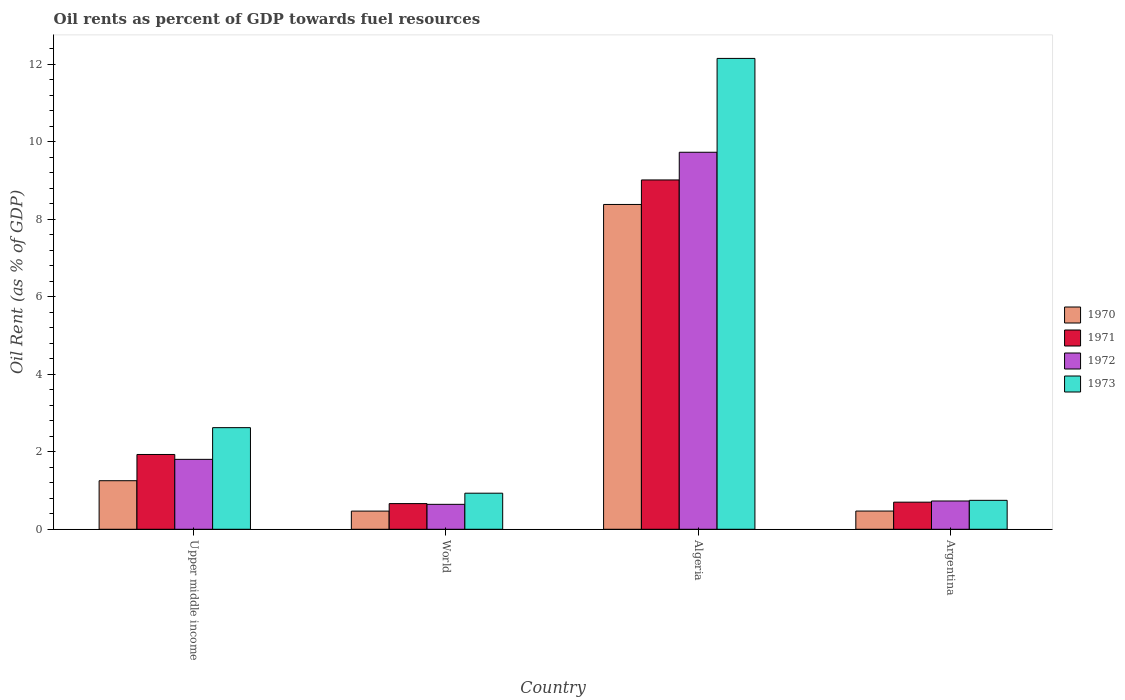How many different coloured bars are there?
Provide a succinct answer. 4. How many groups of bars are there?
Provide a short and direct response. 4. Are the number of bars on each tick of the X-axis equal?
Make the answer very short. Yes. What is the label of the 2nd group of bars from the left?
Your answer should be very brief. World. In how many cases, is the number of bars for a given country not equal to the number of legend labels?
Provide a succinct answer. 0. What is the oil rent in 1970 in World?
Provide a succinct answer. 0.47. Across all countries, what is the maximum oil rent in 1973?
Provide a succinct answer. 12.15. Across all countries, what is the minimum oil rent in 1971?
Ensure brevity in your answer.  0.66. In which country was the oil rent in 1970 maximum?
Make the answer very short. Algeria. What is the total oil rent in 1972 in the graph?
Your answer should be very brief. 12.91. What is the difference between the oil rent in 1971 in Algeria and that in World?
Keep it short and to the point. 8.35. What is the difference between the oil rent in 1971 in Algeria and the oil rent in 1972 in World?
Your answer should be compact. 8.37. What is the average oil rent in 1971 per country?
Ensure brevity in your answer.  3.08. What is the difference between the oil rent of/in 1970 and oil rent of/in 1971 in Upper middle income?
Provide a short and direct response. -0.68. In how many countries, is the oil rent in 1970 greater than 1.6 %?
Make the answer very short. 1. What is the ratio of the oil rent in 1971 in Algeria to that in Upper middle income?
Provide a succinct answer. 4.67. What is the difference between the highest and the second highest oil rent in 1973?
Make the answer very short. -1.69. What is the difference between the highest and the lowest oil rent in 1971?
Provide a succinct answer. 8.35. In how many countries, is the oil rent in 1973 greater than the average oil rent in 1973 taken over all countries?
Your response must be concise. 1. What does the 4th bar from the left in Upper middle income represents?
Your answer should be very brief. 1973. Is it the case that in every country, the sum of the oil rent in 1971 and oil rent in 1972 is greater than the oil rent in 1973?
Provide a short and direct response. Yes. How many countries are there in the graph?
Keep it short and to the point. 4. What is the difference between two consecutive major ticks on the Y-axis?
Ensure brevity in your answer.  2. Are the values on the major ticks of Y-axis written in scientific E-notation?
Your response must be concise. No. Does the graph contain any zero values?
Offer a very short reply. No. Does the graph contain grids?
Give a very brief answer. No. How many legend labels are there?
Provide a short and direct response. 4. How are the legend labels stacked?
Keep it short and to the point. Vertical. What is the title of the graph?
Keep it short and to the point. Oil rents as percent of GDP towards fuel resources. What is the label or title of the X-axis?
Provide a succinct answer. Country. What is the label or title of the Y-axis?
Make the answer very short. Oil Rent (as % of GDP). What is the Oil Rent (as % of GDP) of 1970 in Upper middle income?
Make the answer very short. 1.25. What is the Oil Rent (as % of GDP) of 1971 in Upper middle income?
Ensure brevity in your answer.  1.93. What is the Oil Rent (as % of GDP) in 1972 in Upper middle income?
Ensure brevity in your answer.  1.8. What is the Oil Rent (as % of GDP) in 1973 in Upper middle income?
Offer a very short reply. 2.62. What is the Oil Rent (as % of GDP) in 1970 in World?
Offer a terse response. 0.47. What is the Oil Rent (as % of GDP) in 1971 in World?
Offer a very short reply. 0.66. What is the Oil Rent (as % of GDP) in 1972 in World?
Provide a succinct answer. 0.64. What is the Oil Rent (as % of GDP) of 1973 in World?
Give a very brief answer. 0.93. What is the Oil Rent (as % of GDP) in 1970 in Algeria?
Give a very brief answer. 8.38. What is the Oil Rent (as % of GDP) in 1971 in Algeria?
Offer a terse response. 9.02. What is the Oil Rent (as % of GDP) of 1972 in Algeria?
Your answer should be very brief. 9.73. What is the Oil Rent (as % of GDP) in 1973 in Algeria?
Keep it short and to the point. 12.15. What is the Oil Rent (as % of GDP) of 1970 in Argentina?
Offer a terse response. 0.47. What is the Oil Rent (as % of GDP) of 1971 in Argentina?
Keep it short and to the point. 0.7. What is the Oil Rent (as % of GDP) of 1972 in Argentina?
Your response must be concise. 0.73. What is the Oil Rent (as % of GDP) in 1973 in Argentina?
Give a very brief answer. 0.75. Across all countries, what is the maximum Oil Rent (as % of GDP) in 1970?
Give a very brief answer. 8.38. Across all countries, what is the maximum Oil Rent (as % of GDP) of 1971?
Ensure brevity in your answer.  9.02. Across all countries, what is the maximum Oil Rent (as % of GDP) of 1972?
Keep it short and to the point. 9.73. Across all countries, what is the maximum Oil Rent (as % of GDP) in 1973?
Ensure brevity in your answer.  12.15. Across all countries, what is the minimum Oil Rent (as % of GDP) of 1970?
Offer a terse response. 0.47. Across all countries, what is the minimum Oil Rent (as % of GDP) of 1971?
Your answer should be compact. 0.66. Across all countries, what is the minimum Oil Rent (as % of GDP) of 1972?
Offer a very short reply. 0.64. Across all countries, what is the minimum Oil Rent (as % of GDP) of 1973?
Your answer should be very brief. 0.75. What is the total Oil Rent (as % of GDP) in 1970 in the graph?
Offer a very short reply. 10.58. What is the total Oil Rent (as % of GDP) of 1971 in the graph?
Provide a succinct answer. 12.31. What is the total Oil Rent (as % of GDP) in 1972 in the graph?
Your response must be concise. 12.91. What is the total Oil Rent (as % of GDP) of 1973 in the graph?
Keep it short and to the point. 16.45. What is the difference between the Oil Rent (as % of GDP) of 1970 in Upper middle income and that in World?
Your response must be concise. 0.78. What is the difference between the Oil Rent (as % of GDP) in 1971 in Upper middle income and that in World?
Your answer should be very brief. 1.27. What is the difference between the Oil Rent (as % of GDP) of 1972 in Upper middle income and that in World?
Make the answer very short. 1.16. What is the difference between the Oil Rent (as % of GDP) of 1973 in Upper middle income and that in World?
Offer a very short reply. 1.69. What is the difference between the Oil Rent (as % of GDP) of 1970 in Upper middle income and that in Algeria?
Ensure brevity in your answer.  -7.13. What is the difference between the Oil Rent (as % of GDP) in 1971 in Upper middle income and that in Algeria?
Make the answer very short. -7.09. What is the difference between the Oil Rent (as % of GDP) of 1972 in Upper middle income and that in Algeria?
Ensure brevity in your answer.  -7.93. What is the difference between the Oil Rent (as % of GDP) in 1973 in Upper middle income and that in Algeria?
Offer a terse response. -9.53. What is the difference between the Oil Rent (as % of GDP) of 1970 in Upper middle income and that in Argentina?
Your answer should be very brief. 0.78. What is the difference between the Oil Rent (as % of GDP) in 1971 in Upper middle income and that in Argentina?
Your response must be concise. 1.23. What is the difference between the Oil Rent (as % of GDP) of 1972 in Upper middle income and that in Argentina?
Provide a succinct answer. 1.07. What is the difference between the Oil Rent (as % of GDP) of 1973 in Upper middle income and that in Argentina?
Offer a terse response. 1.88. What is the difference between the Oil Rent (as % of GDP) in 1970 in World and that in Algeria?
Offer a very short reply. -7.91. What is the difference between the Oil Rent (as % of GDP) in 1971 in World and that in Algeria?
Provide a succinct answer. -8.35. What is the difference between the Oil Rent (as % of GDP) of 1972 in World and that in Algeria?
Offer a very short reply. -9.09. What is the difference between the Oil Rent (as % of GDP) of 1973 in World and that in Algeria?
Provide a short and direct response. -11.22. What is the difference between the Oil Rent (as % of GDP) of 1970 in World and that in Argentina?
Give a very brief answer. -0. What is the difference between the Oil Rent (as % of GDP) in 1971 in World and that in Argentina?
Your answer should be compact. -0.04. What is the difference between the Oil Rent (as % of GDP) of 1972 in World and that in Argentina?
Your answer should be very brief. -0.09. What is the difference between the Oil Rent (as % of GDP) of 1973 in World and that in Argentina?
Keep it short and to the point. 0.18. What is the difference between the Oil Rent (as % of GDP) of 1970 in Algeria and that in Argentina?
Provide a short and direct response. 7.91. What is the difference between the Oil Rent (as % of GDP) in 1971 in Algeria and that in Argentina?
Keep it short and to the point. 8.32. What is the difference between the Oil Rent (as % of GDP) in 1972 in Algeria and that in Argentina?
Your response must be concise. 9. What is the difference between the Oil Rent (as % of GDP) in 1973 in Algeria and that in Argentina?
Your response must be concise. 11.41. What is the difference between the Oil Rent (as % of GDP) of 1970 in Upper middle income and the Oil Rent (as % of GDP) of 1971 in World?
Offer a terse response. 0.59. What is the difference between the Oil Rent (as % of GDP) in 1970 in Upper middle income and the Oil Rent (as % of GDP) in 1972 in World?
Your answer should be very brief. 0.61. What is the difference between the Oil Rent (as % of GDP) in 1970 in Upper middle income and the Oil Rent (as % of GDP) in 1973 in World?
Offer a very short reply. 0.32. What is the difference between the Oil Rent (as % of GDP) of 1971 in Upper middle income and the Oil Rent (as % of GDP) of 1972 in World?
Your response must be concise. 1.29. What is the difference between the Oil Rent (as % of GDP) of 1972 in Upper middle income and the Oil Rent (as % of GDP) of 1973 in World?
Provide a short and direct response. 0.87. What is the difference between the Oil Rent (as % of GDP) of 1970 in Upper middle income and the Oil Rent (as % of GDP) of 1971 in Algeria?
Your answer should be very brief. -7.76. What is the difference between the Oil Rent (as % of GDP) in 1970 in Upper middle income and the Oil Rent (as % of GDP) in 1972 in Algeria?
Offer a terse response. -8.48. What is the difference between the Oil Rent (as % of GDP) in 1970 in Upper middle income and the Oil Rent (as % of GDP) in 1973 in Algeria?
Your response must be concise. -10.9. What is the difference between the Oil Rent (as % of GDP) in 1971 in Upper middle income and the Oil Rent (as % of GDP) in 1973 in Algeria?
Provide a succinct answer. -10.22. What is the difference between the Oil Rent (as % of GDP) of 1972 in Upper middle income and the Oil Rent (as % of GDP) of 1973 in Algeria?
Give a very brief answer. -10.35. What is the difference between the Oil Rent (as % of GDP) of 1970 in Upper middle income and the Oil Rent (as % of GDP) of 1971 in Argentina?
Offer a terse response. 0.55. What is the difference between the Oil Rent (as % of GDP) of 1970 in Upper middle income and the Oil Rent (as % of GDP) of 1972 in Argentina?
Make the answer very short. 0.52. What is the difference between the Oil Rent (as % of GDP) of 1970 in Upper middle income and the Oil Rent (as % of GDP) of 1973 in Argentina?
Your response must be concise. 0.51. What is the difference between the Oil Rent (as % of GDP) in 1971 in Upper middle income and the Oil Rent (as % of GDP) in 1972 in Argentina?
Ensure brevity in your answer.  1.2. What is the difference between the Oil Rent (as % of GDP) of 1971 in Upper middle income and the Oil Rent (as % of GDP) of 1973 in Argentina?
Make the answer very short. 1.18. What is the difference between the Oil Rent (as % of GDP) of 1972 in Upper middle income and the Oil Rent (as % of GDP) of 1973 in Argentina?
Your answer should be very brief. 1.06. What is the difference between the Oil Rent (as % of GDP) in 1970 in World and the Oil Rent (as % of GDP) in 1971 in Algeria?
Offer a terse response. -8.55. What is the difference between the Oil Rent (as % of GDP) in 1970 in World and the Oil Rent (as % of GDP) in 1972 in Algeria?
Provide a succinct answer. -9.26. What is the difference between the Oil Rent (as % of GDP) of 1970 in World and the Oil Rent (as % of GDP) of 1973 in Algeria?
Keep it short and to the point. -11.68. What is the difference between the Oil Rent (as % of GDP) of 1971 in World and the Oil Rent (as % of GDP) of 1972 in Algeria?
Provide a short and direct response. -9.07. What is the difference between the Oil Rent (as % of GDP) in 1971 in World and the Oil Rent (as % of GDP) in 1973 in Algeria?
Keep it short and to the point. -11.49. What is the difference between the Oil Rent (as % of GDP) of 1972 in World and the Oil Rent (as % of GDP) of 1973 in Algeria?
Keep it short and to the point. -11.51. What is the difference between the Oil Rent (as % of GDP) in 1970 in World and the Oil Rent (as % of GDP) in 1971 in Argentina?
Your answer should be very brief. -0.23. What is the difference between the Oil Rent (as % of GDP) of 1970 in World and the Oil Rent (as % of GDP) of 1972 in Argentina?
Give a very brief answer. -0.26. What is the difference between the Oil Rent (as % of GDP) of 1970 in World and the Oil Rent (as % of GDP) of 1973 in Argentina?
Your response must be concise. -0.28. What is the difference between the Oil Rent (as % of GDP) of 1971 in World and the Oil Rent (as % of GDP) of 1972 in Argentina?
Offer a very short reply. -0.07. What is the difference between the Oil Rent (as % of GDP) of 1971 in World and the Oil Rent (as % of GDP) of 1973 in Argentina?
Provide a succinct answer. -0.08. What is the difference between the Oil Rent (as % of GDP) of 1972 in World and the Oil Rent (as % of GDP) of 1973 in Argentina?
Your response must be concise. -0.1. What is the difference between the Oil Rent (as % of GDP) of 1970 in Algeria and the Oil Rent (as % of GDP) of 1971 in Argentina?
Your response must be concise. 7.68. What is the difference between the Oil Rent (as % of GDP) of 1970 in Algeria and the Oil Rent (as % of GDP) of 1972 in Argentina?
Your response must be concise. 7.65. What is the difference between the Oil Rent (as % of GDP) in 1970 in Algeria and the Oil Rent (as % of GDP) in 1973 in Argentina?
Offer a terse response. 7.64. What is the difference between the Oil Rent (as % of GDP) of 1971 in Algeria and the Oil Rent (as % of GDP) of 1972 in Argentina?
Your answer should be very brief. 8.29. What is the difference between the Oil Rent (as % of GDP) of 1971 in Algeria and the Oil Rent (as % of GDP) of 1973 in Argentina?
Provide a succinct answer. 8.27. What is the difference between the Oil Rent (as % of GDP) of 1972 in Algeria and the Oil Rent (as % of GDP) of 1973 in Argentina?
Give a very brief answer. 8.98. What is the average Oil Rent (as % of GDP) of 1970 per country?
Your response must be concise. 2.64. What is the average Oil Rent (as % of GDP) of 1971 per country?
Your response must be concise. 3.08. What is the average Oil Rent (as % of GDP) of 1972 per country?
Your answer should be compact. 3.23. What is the average Oil Rent (as % of GDP) of 1973 per country?
Keep it short and to the point. 4.11. What is the difference between the Oil Rent (as % of GDP) of 1970 and Oil Rent (as % of GDP) of 1971 in Upper middle income?
Keep it short and to the point. -0.68. What is the difference between the Oil Rent (as % of GDP) in 1970 and Oil Rent (as % of GDP) in 1972 in Upper middle income?
Your response must be concise. -0.55. What is the difference between the Oil Rent (as % of GDP) in 1970 and Oil Rent (as % of GDP) in 1973 in Upper middle income?
Your response must be concise. -1.37. What is the difference between the Oil Rent (as % of GDP) of 1971 and Oil Rent (as % of GDP) of 1972 in Upper middle income?
Provide a short and direct response. 0.13. What is the difference between the Oil Rent (as % of GDP) of 1971 and Oil Rent (as % of GDP) of 1973 in Upper middle income?
Your answer should be very brief. -0.69. What is the difference between the Oil Rent (as % of GDP) in 1972 and Oil Rent (as % of GDP) in 1973 in Upper middle income?
Provide a succinct answer. -0.82. What is the difference between the Oil Rent (as % of GDP) of 1970 and Oil Rent (as % of GDP) of 1971 in World?
Offer a terse response. -0.19. What is the difference between the Oil Rent (as % of GDP) in 1970 and Oil Rent (as % of GDP) in 1972 in World?
Provide a succinct answer. -0.17. What is the difference between the Oil Rent (as % of GDP) in 1970 and Oil Rent (as % of GDP) in 1973 in World?
Keep it short and to the point. -0.46. What is the difference between the Oil Rent (as % of GDP) in 1971 and Oil Rent (as % of GDP) in 1972 in World?
Offer a terse response. 0.02. What is the difference between the Oil Rent (as % of GDP) of 1971 and Oil Rent (as % of GDP) of 1973 in World?
Offer a very short reply. -0.27. What is the difference between the Oil Rent (as % of GDP) in 1972 and Oil Rent (as % of GDP) in 1973 in World?
Your response must be concise. -0.29. What is the difference between the Oil Rent (as % of GDP) in 1970 and Oil Rent (as % of GDP) in 1971 in Algeria?
Provide a succinct answer. -0.63. What is the difference between the Oil Rent (as % of GDP) of 1970 and Oil Rent (as % of GDP) of 1972 in Algeria?
Your answer should be compact. -1.35. What is the difference between the Oil Rent (as % of GDP) in 1970 and Oil Rent (as % of GDP) in 1973 in Algeria?
Offer a terse response. -3.77. What is the difference between the Oil Rent (as % of GDP) of 1971 and Oil Rent (as % of GDP) of 1972 in Algeria?
Offer a terse response. -0.71. What is the difference between the Oil Rent (as % of GDP) of 1971 and Oil Rent (as % of GDP) of 1973 in Algeria?
Provide a succinct answer. -3.14. What is the difference between the Oil Rent (as % of GDP) of 1972 and Oil Rent (as % of GDP) of 1973 in Algeria?
Keep it short and to the point. -2.42. What is the difference between the Oil Rent (as % of GDP) of 1970 and Oil Rent (as % of GDP) of 1971 in Argentina?
Your answer should be compact. -0.23. What is the difference between the Oil Rent (as % of GDP) of 1970 and Oil Rent (as % of GDP) of 1972 in Argentina?
Keep it short and to the point. -0.26. What is the difference between the Oil Rent (as % of GDP) in 1970 and Oil Rent (as % of GDP) in 1973 in Argentina?
Ensure brevity in your answer.  -0.28. What is the difference between the Oil Rent (as % of GDP) in 1971 and Oil Rent (as % of GDP) in 1972 in Argentina?
Provide a succinct answer. -0.03. What is the difference between the Oil Rent (as % of GDP) in 1971 and Oil Rent (as % of GDP) in 1973 in Argentina?
Your answer should be compact. -0.05. What is the difference between the Oil Rent (as % of GDP) in 1972 and Oil Rent (as % of GDP) in 1973 in Argentina?
Provide a succinct answer. -0.02. What is the ratio of the Oil Rent (as % of GDP) in 1970 in Upper middle income to that in World?
Your answer should be very brief. 2.67. What is the ratio of the Oil Rent (as % of GDP) of 1971 in Upper middle income to that in World?
Offer a very short reply. 2.91. What is the ratio of the Oil Rent (as % of GDP) of 1972 in Upper middle income to that in World?
Give a very brief answer. 2.8. What is the ratio of the Oil Rent (as % of GDP) of 1973 in Upper middle income to that in World?
Provide a succinct answer. 2.82. What is the ratio of the Oil Rent (as % of GDP) in 1970 in Upper middle income to that in Algeria?
Provide a succinct answer. 0.15. What is the ratio of the Oil Rent (as % of GDP) in 1971 in Upper middle income to that in Algeria?
Offer a very short reply. 0.21. What is the ratio of the Oil Rent (as % of GDP) of 1972 in Upper middle income to that in Algeria?
Provide a short and direct response. 0.19. What is the ratio of the Oil Rent (as % of GDP) in 1973 in Upper middle income to that in Algeria?
Make the answer very short. 0.22. What is the ratio of the Oil Rent (as % of GDP) in 1970 in Upper middle income to that in Argentina?
Your answer should be very brief. 2.67. What is the ratio of the Oil Rent (as % of GDP) of 1971 in Upper middle income to that in Argentina?
Provide a short and direct response. 2.76. What is the ratio of the Oil Rent (as % of GDP) of 1972 in Upper middle income to that in Argentina?
Your response must be concise. 2.47. What is the ratio of the Oil Rent (as % of GDP) of 1973 in Upper middle income to that in Argentina?
Offer a terse response. 3.51. What is the ratio of the Oil Rent (as % of GDP) of 1970 in World to that in Algeria?
Provide a succinct answer. 0.06. What is the ratio of the Oil Rent (as % of GDP) of 1971 in World to that in Algeria?
Your answer should be compact. 0.07. What is the ratio of the Oil Rent (as % of GDP) of 1972 in World to that in Algeria?
Your answer should be very brief. 0.07. What is the ratio of the Oil Rent (as % of GDP) of 1973 in World to that in Algeria?
Provide a short and direct response. 0.08. What is the ratio of the Oil Rent (as % of GDP) of 1970 in World to that in Argentina?
Give a very brief answer. 1. What is the ratio of the Oil Rent (as % of GDP) in 1971 in World to that in Argentina?
Provide a short and direct response. 0.95. What is the ratio of the Oil Rent (as % of GDP) in 1972 in World to that in Argentina?
Your answer should be compact. 0.88. What is the ratio of the Oil Rent (as % of GDP) in 1973 in World to that in Argentina?
Ensure brevity in your answer.  1.25. What is the ratio of the Oil Rent (as % of GDP) of 1970 in Algeria to that in Argentina?
Your response must be concise. 17.83. What is the ratio of the Oil Rent (as % of GDP) in 1971 in Algeria to that in Argentina?
Give a very brief answer. 12.88. What is the ratio of the Oil Rent (as % of GDP) of 1972 in Algeria to that in Argentina?
Ensure brevity in your answer.  13.33. What is the ratio of the Oil Rent (as % of GDP) of 1973 in Algeria to that in Argentina?
Make the answer very short. 16.27. What is the difference between the highest and the second highest Oil Rent (as % of GDP) of 1970?
Offer a very short reply. 7.13. What is the difference between the highest and the second highest Oil Rent (as % of GDP) in 1971?
Provide a succinct answer. 7.09. What is the difference between the highest and the second highest Oil Rent (as % of GDP) in 1972?
Provide a succinct answer. 7.93. What is the difference between the highest and the second highest Oil Rent (as % of GDP) in 1973?
Offer a very short reply. 9.53. What is the difference between the highest and the lowest Oil Rent (as % of GDP) of 1970?
Provide a short and direct response. 7.91. What is the difference between the highest and the lowest Oil Rent (as % of GDP) in 1971?
Provide a short and direct response. 8.35. What is the difference between the highest and the lowest Oil Rent (as % of GDP) of 1972?
Offer a very short reply. 9.09. What is the difference between the highest and the lowest Oil Rent (as % of GDP) in 1973?
Your response must be concise. 11.41. 